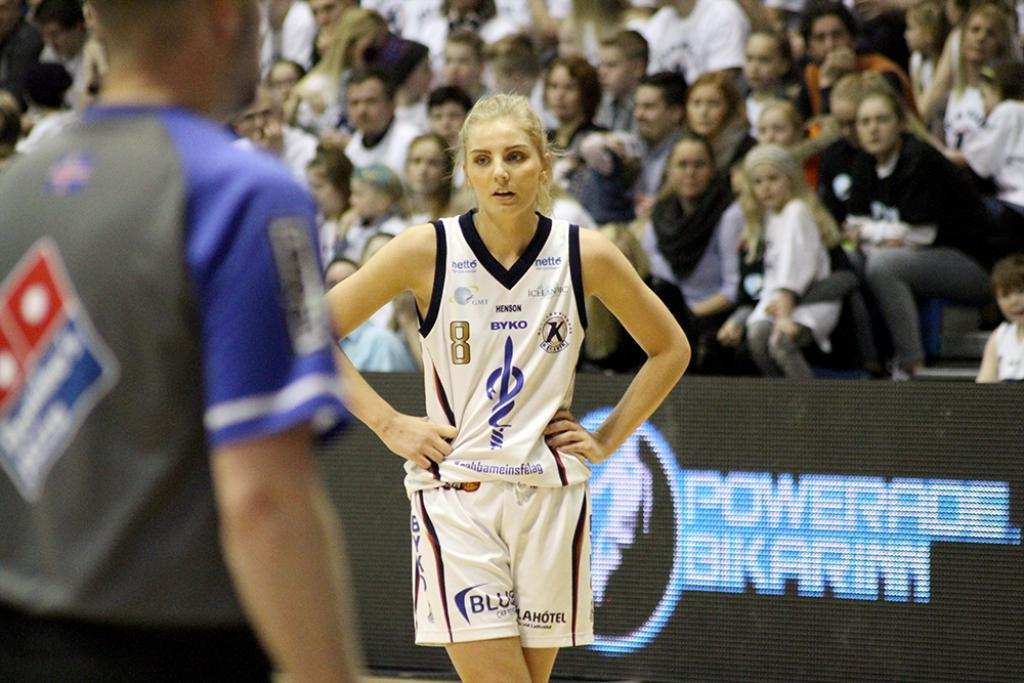<image>
Give a short and clear explanation of the subsequent image. Blonde woman playing basketball in a jersey featuring a host of ads such as "Blue". 